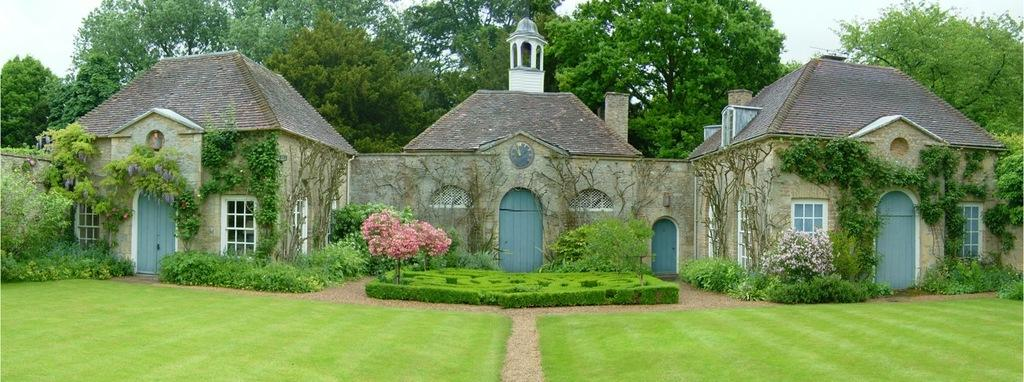What type of vegetation can be seen in the image? There is grass, plants, and trees in the image. What architectural features are present in the image? There are doors and windows in the image. What type of structures are visible in the image? There are houses in the image. Can you describe the flock of dinosaurs grazing on the grass in the image? There are no dinosaurs present in the image; it features grass, plants, trees, doors, windows, and houses. What type of bed can be seen in the image? There is no bed visible in the image. 